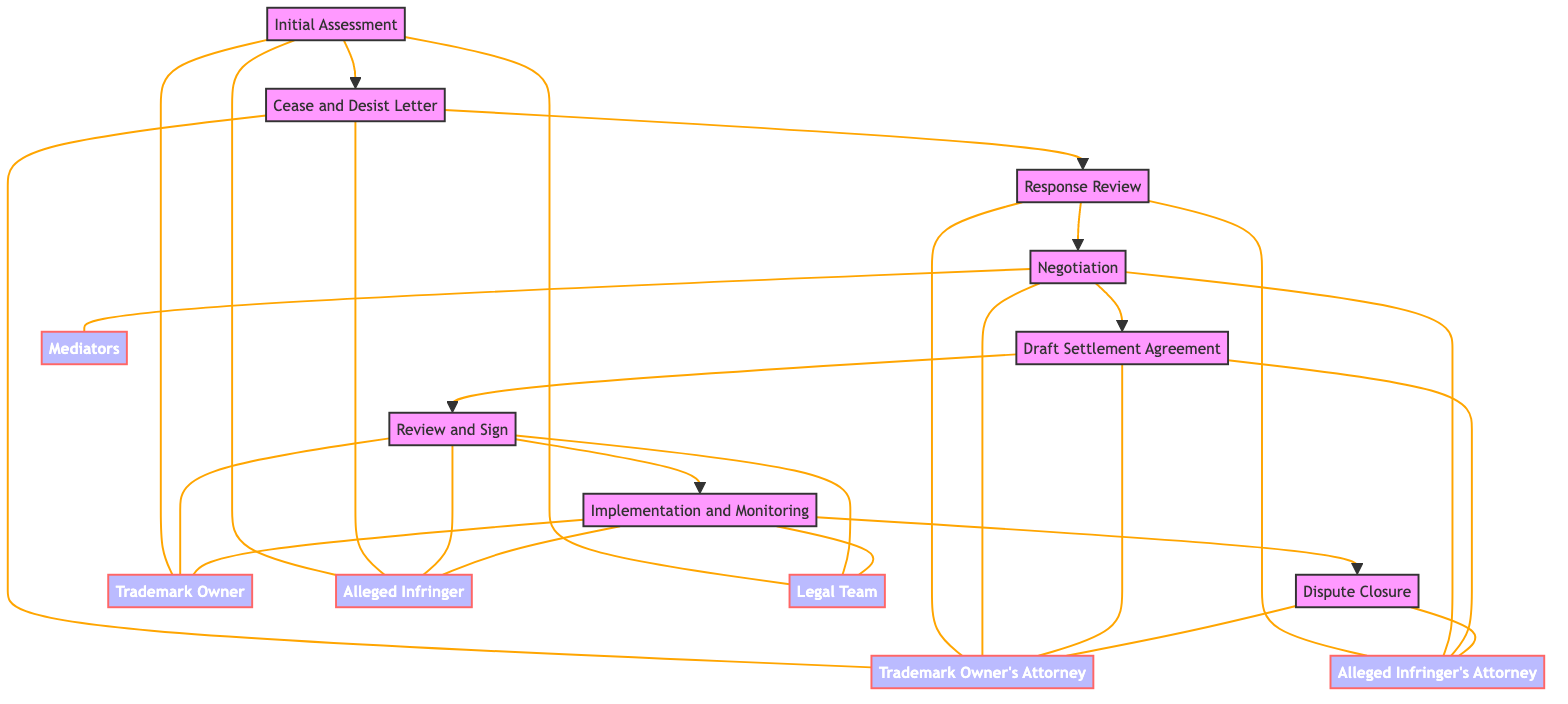What is the first step in the process? The diagram lists "Initial Assessment" as the first step, indicating that this is the starting point of the process for negotiating a settlement in trademark disputes.
Answer: Initial Assessment How many steps are in the process? The diagram contains a total of eight distinct steps, which outlines the complete procedure from initial assessment to dispute closure.
Answer: 8 Which step involves sending a formal letter? According to the diagram, the step labeled "Cease and Desist Letter" is the one that involves sending a formal letter to the alleged infringer.
Answer: Cease and Desist Letter Who is involved in the "Negotiation" step? The "Negotiation" step includes the Trademark Owner's Attorney, Alleged Infringer's Attorney, and any Mediators, who collectively engage in discussions to reach a settlement.
Answer: Trademark Owner's Attorney, Alleged Infringer's Attorney, Mediators What is the last step of the process? The diagram indicates that "Dispute Closure" is the final step in the process for negotiating a settlement in trademark disputes.
Answer: Dispute Closure What comes after "Review and Sign"? In the sequence illustrated in the diagram, "Implementation and Monitoring" directly follows the "Review and Sign" step, indicating the next action to be taken after the agreement is reviewed and signed.
Answer: Implementation and Monitoring Which entities are involved in the "Draft Settlement Agreement"? The diagram specifies that the entities involved in drafting the settlement agreement are both the Trademark Owner's Attorney and the Alleged Infringer's Attorney.
Answer: Trademark Owner's Attorney, Alleged Infringer's Attorney What is the relationship between "Response Review" and "Negotiation"? "Response Review" precedes "Negotiation" in the flowchart, indicating that the review of the alleged infringer's response is a prerequisite for entering negotiation discussions.
Answer: Precedes How many entities are linked to the "Initial Assessment"? The "Initial Assessment" step is connected to three entities: Trademark Owner, Alleged Infringer, and Legal Team, as shown in the diagram.
Answer: 3 